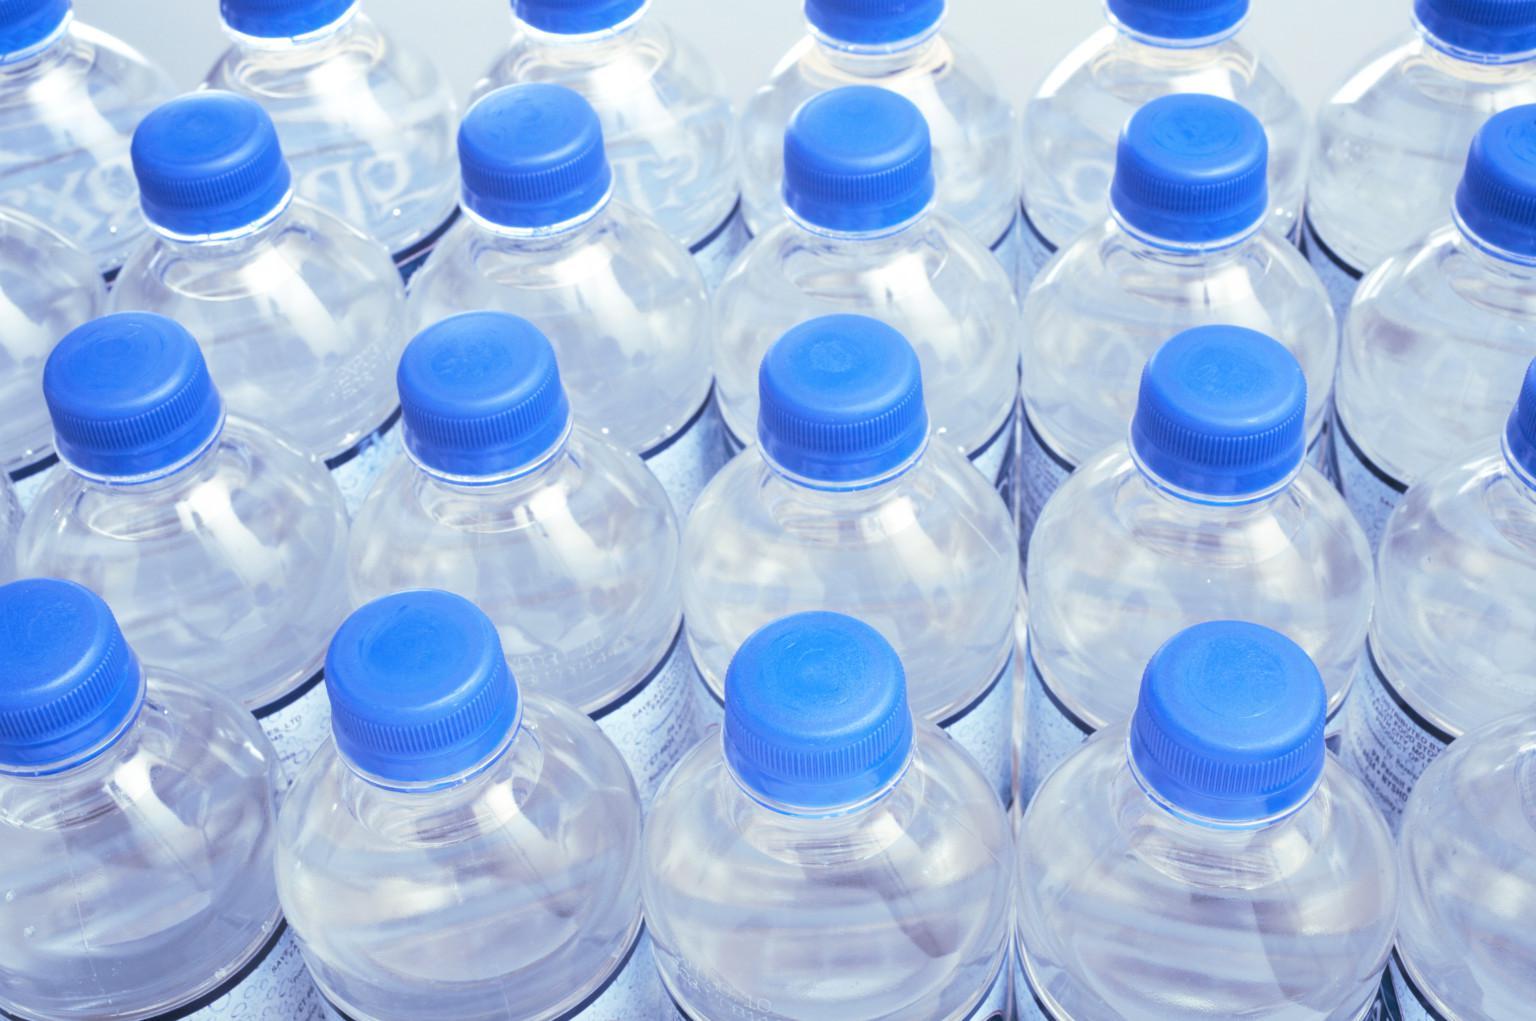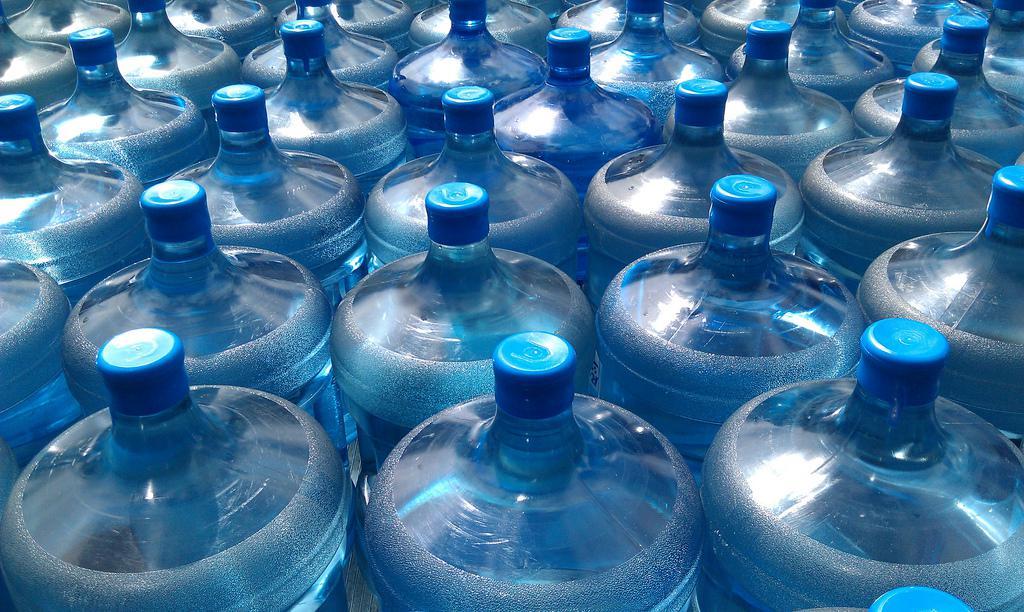The first image is the image on the left, the second image is the image on the right. Given the left and right images, does the statement "The bottles in one of the images are for water coolers" hold true? Answer yes or no. Yes. 